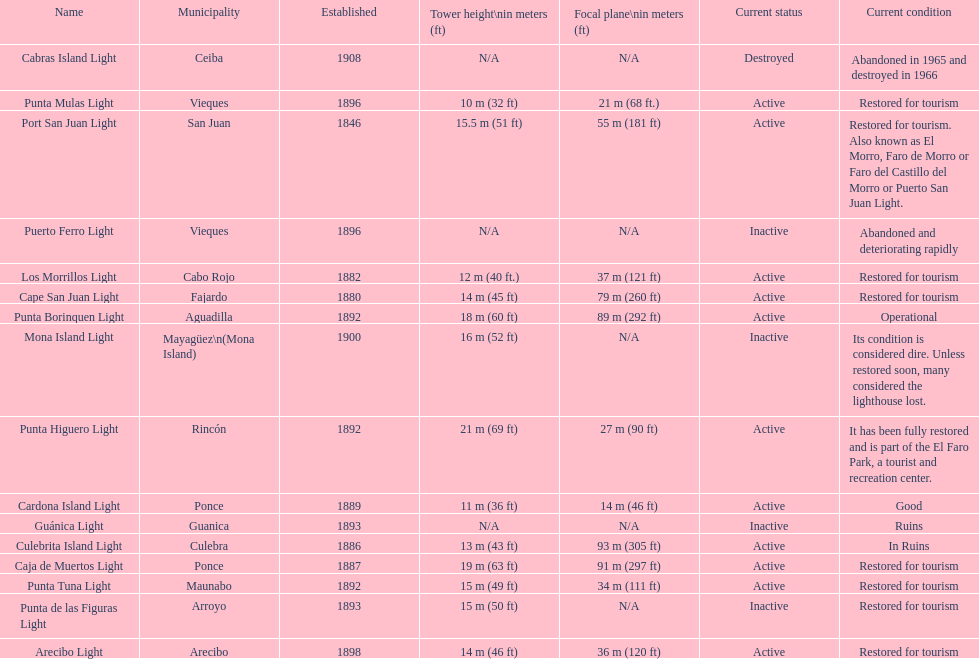How many establishments are restored for tourism? 9. 